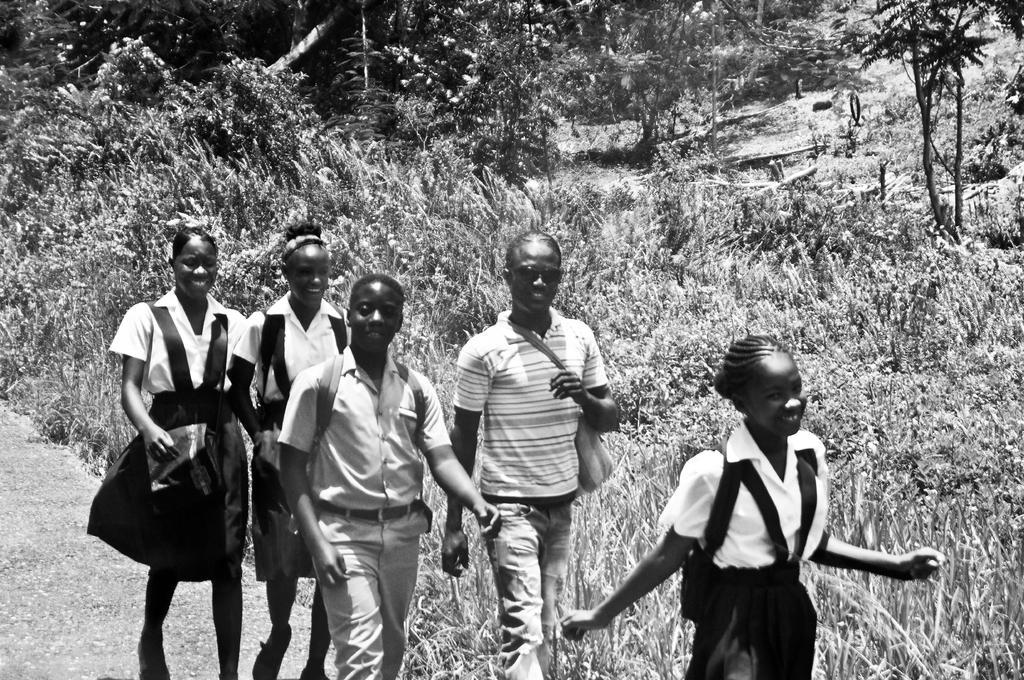Describe this image in one or two sentences. In the middle of the image few people are walking and smiling. Behind them there are some plants and trees. 